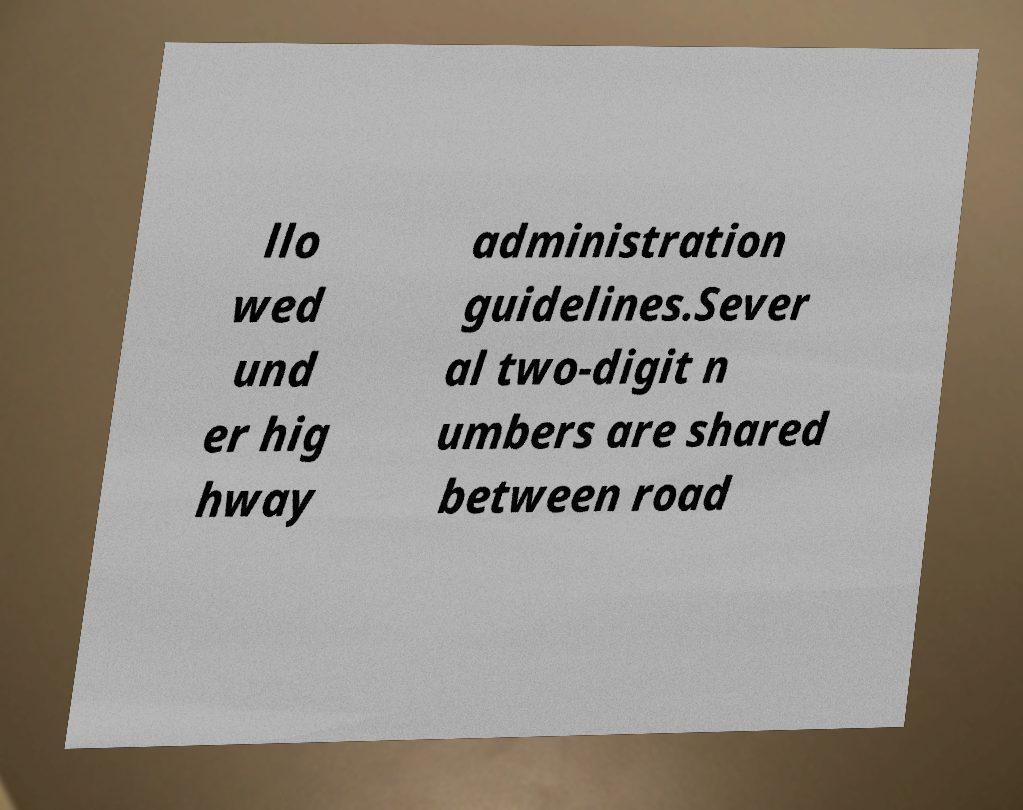Please read and relay the text visible in this image. What does it say? llo wed und er hig hway administration guidelines.Sever al two-digit n umbers are shared between road 